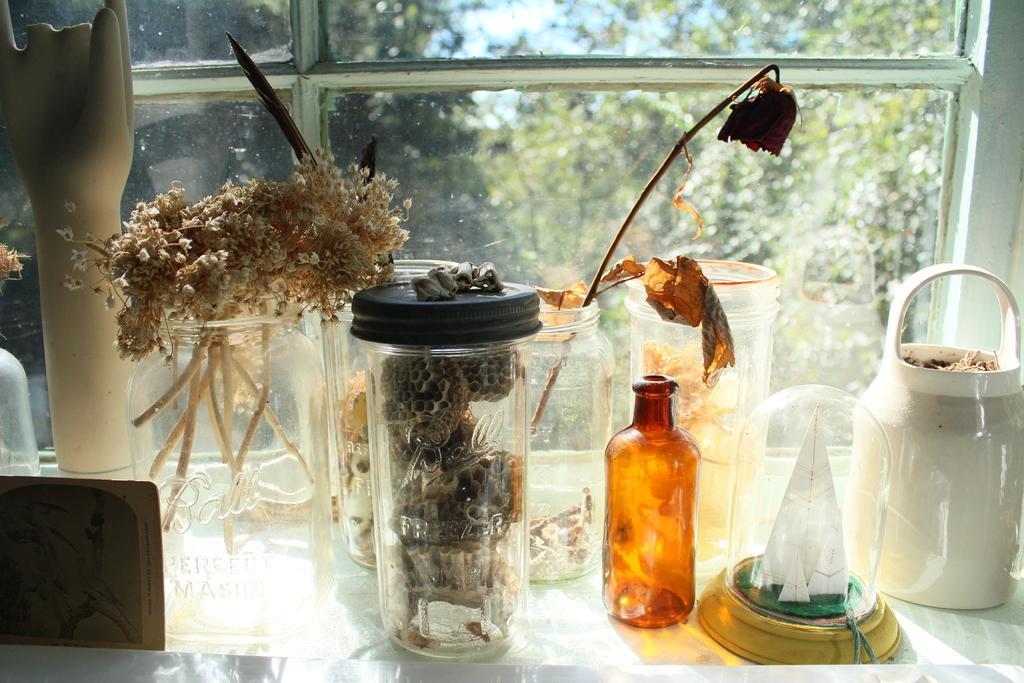Please provide a concise description of this image. There are some glass jars and some dried particles are present in them behind them there is a glass window, outside the window there are number of trees. 